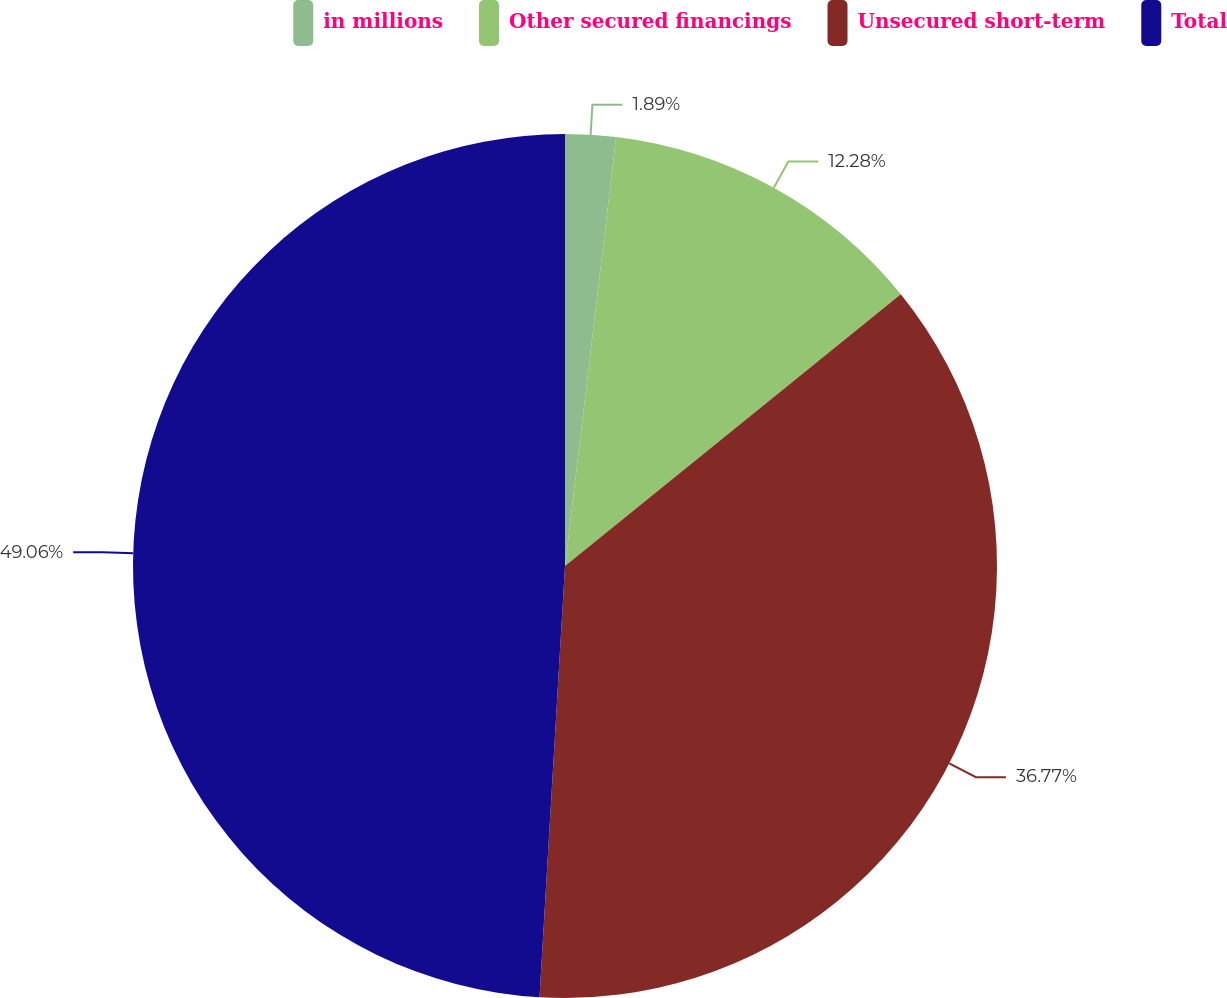Convert chart to OTSL. <chart><loc_0><loc_0><loc_500><loc_500><pie_chart><fcel>in millions<fcel>Other secured financings<fcel>Unsecured short-term<fcel>Total<nl><fcel>1.89%<fcel>12.28%<fcel>36.77%<fcel>49.06%<nl></chart> 